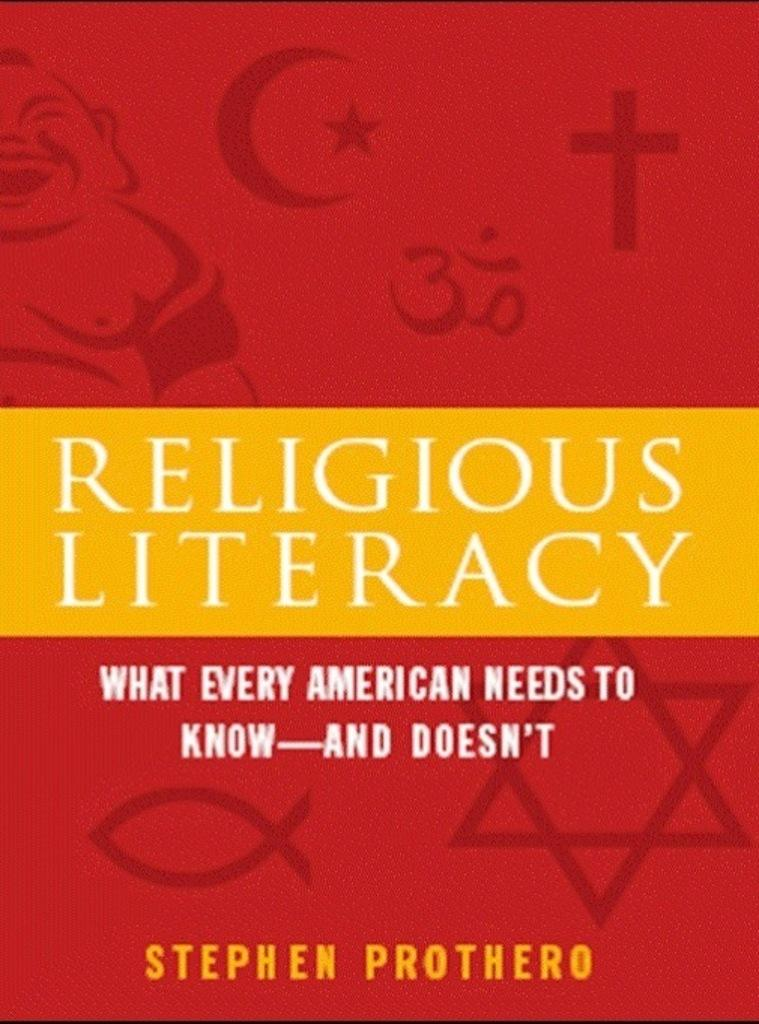Provide a one-sentence caption for the provided image. A book entitles Religious Literacy by Stephen Prothero features a bright red and yellow cover. 